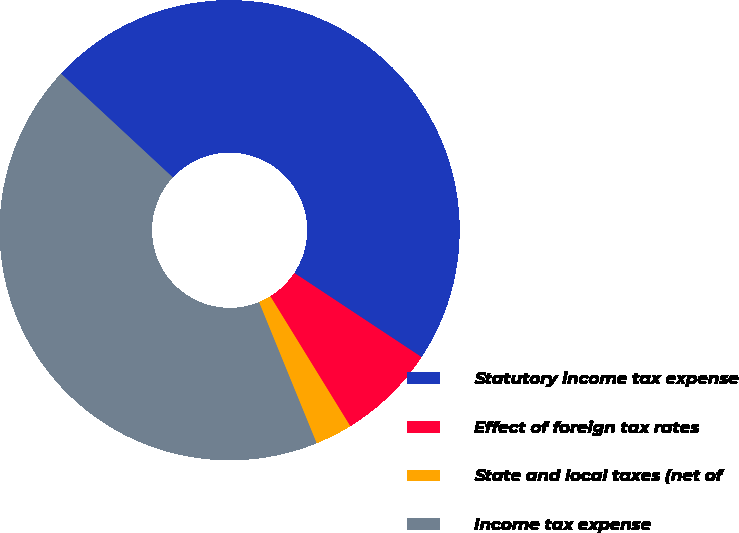<chart> <loc_0><loc_0><loc_500><loc_500><pie_chart><fcel>Statutory income tax expense<fcel>Effect of foreign tax rates<fcel>State and local taxes (net of<fcel>Income tax expense<nl><fcel>47.39%<fcel>6.92%<fcel>2.61%<fcel>43.08%<nl></chart> 